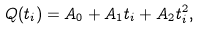<formula> <loc_0><loc_0><loc_500><loc_500>Q ( t _ { i } ) = A _ { 0 } + A _ { 1 } t _ { i } + A _ { 2 } t _ { i } ^ { 2 } ,</formula> 